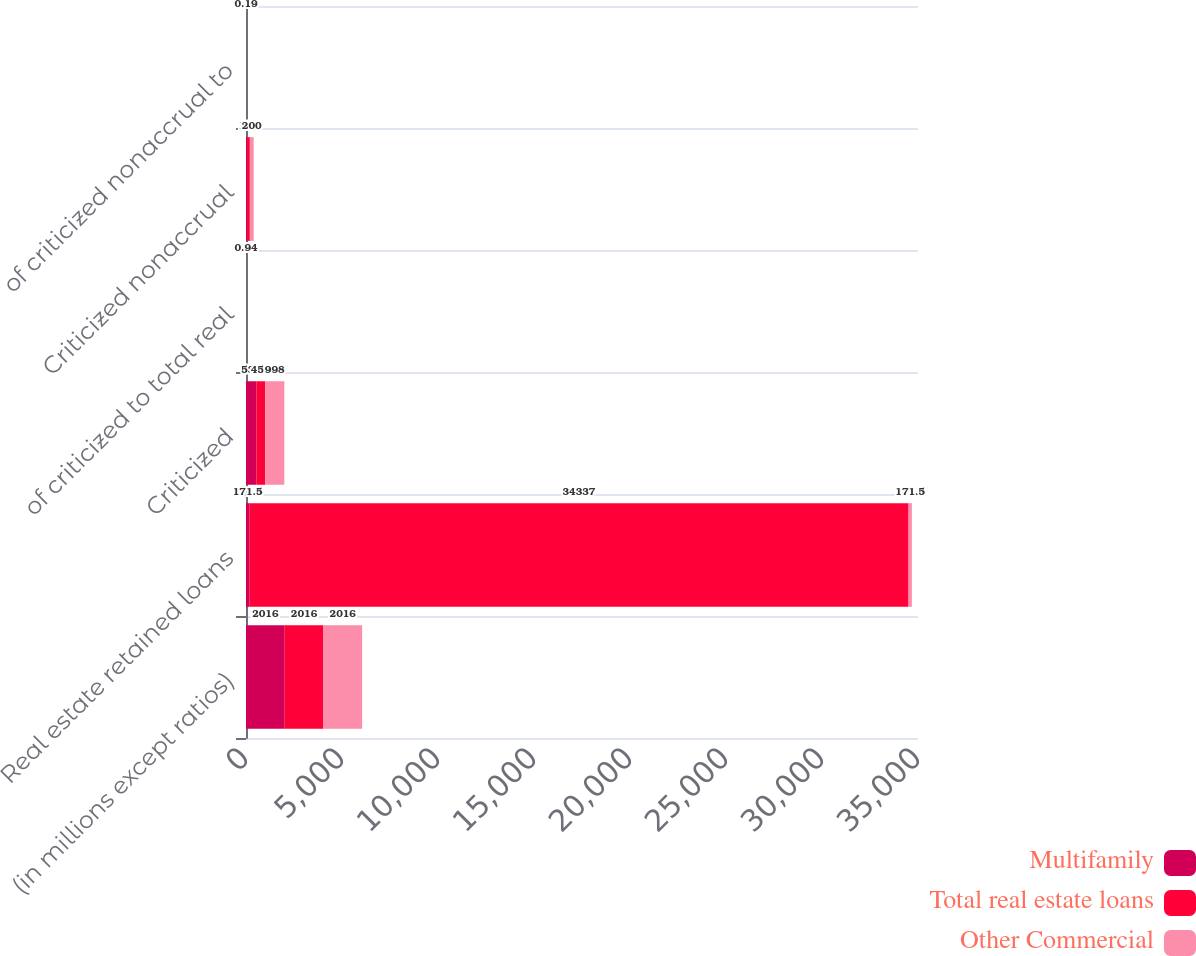Convert chart. <chart><loc_0><loc_0><loc_500><loc_500><stacked_bar_chart><ecel><fcel>(in millions except ratios)<fcel>Real estate retained loans<fcel>Criticized<fcel>of criticized to total real<fcel>Criticized nonaccrual<fcel>of criticized nonaccrual to<nl><fcel>Multifamily<fcel>2016<fcel>171.5<fcel>539<fcel>0.75<fcel>57<fcel>0.08<nl><fcel>Total real estate loans<fcel>2016<fcel>34337<fcel>459<fcel>1.34<fcel>143<fcel>0.42<nl><fcel>Other Commercial<fcel>2016<fcel>171.5<fcel>998<fcel>0.94<fcel>200<fcel>0.19<nl></chart> 